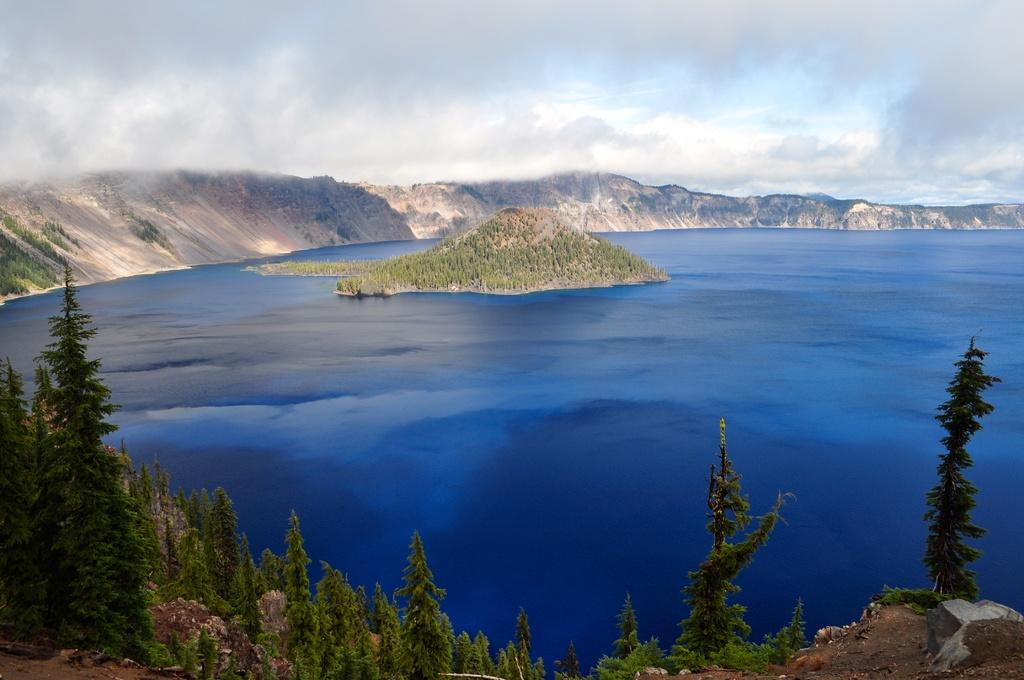What type of landscape is depicted in the image? The image features hills. What natural element can be seen in the image? There is water visible in the image. How would you describe the weather in the image? The sky is cloudy in the image. What type of vegetation is present at the bottom of the image? There are trees at the bottom of the image. Where is the office located in the image? There is no office present in the image; it features a natural landscape with hills, water, and trees. 